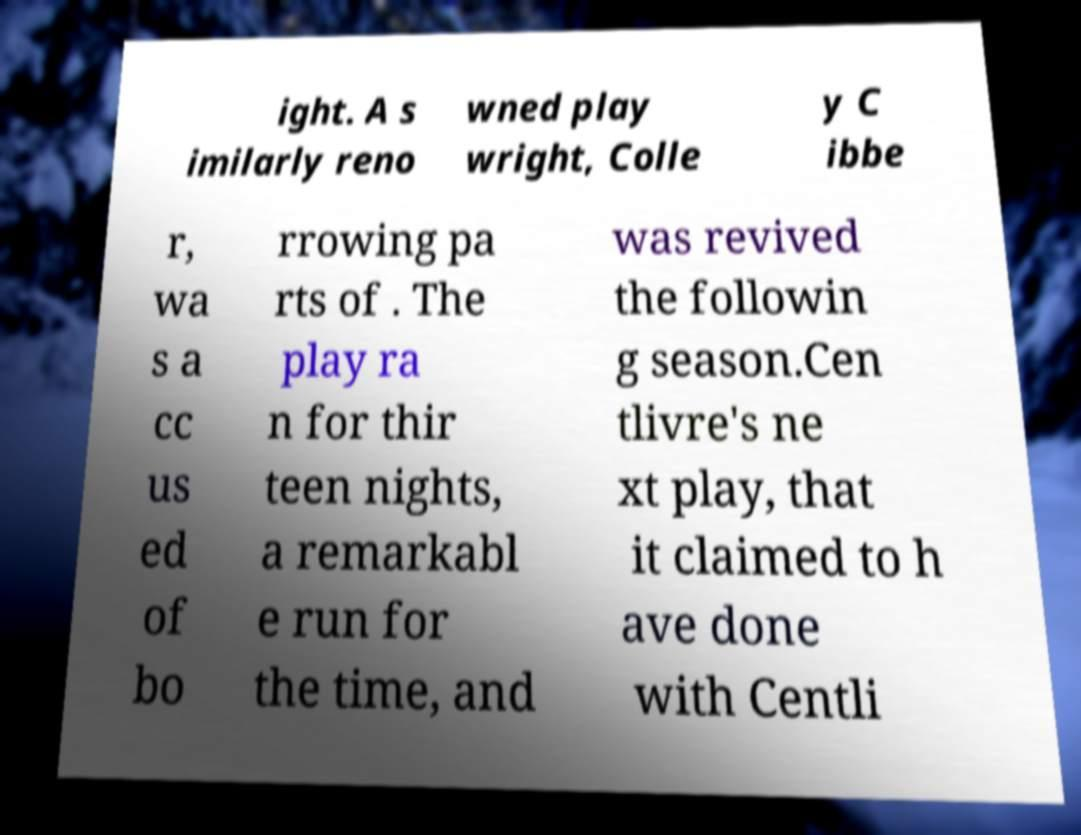There's text embedded in this image that I need extracted. Can you transcribe it verbatim? ight. A s imilarly reno wned play wright, Colle y C ibbe r, wa s a cc us ed of bo rrowing pa rts of . The play ra n for thir teen nights, a remarkabl e run for the time, and was revived the followin g season.Cen tlivre's ne xt play, that it claimed to h ave done with Centli 